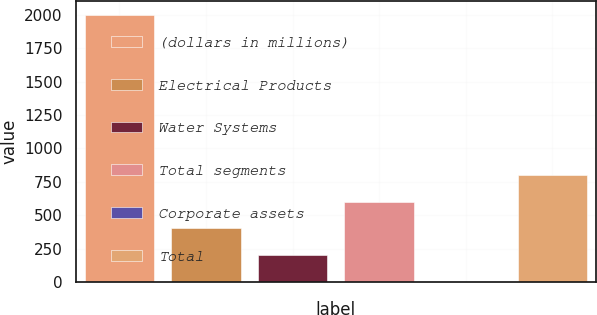Convert chart. <chart><loc_0><loc_0><loc_500><loc_500><bar_chart><fcel>(dollars in millions)<fcel>Electrical Products<fcel>Water Systems<fcel>Total segments<fcel>Corporate assets<fcel>Total<nl><fcel>2002<fcel>400.96<fcel>200.83<fcel>601.09<fcel>0.7<fcel>801.22<nl></chart> 